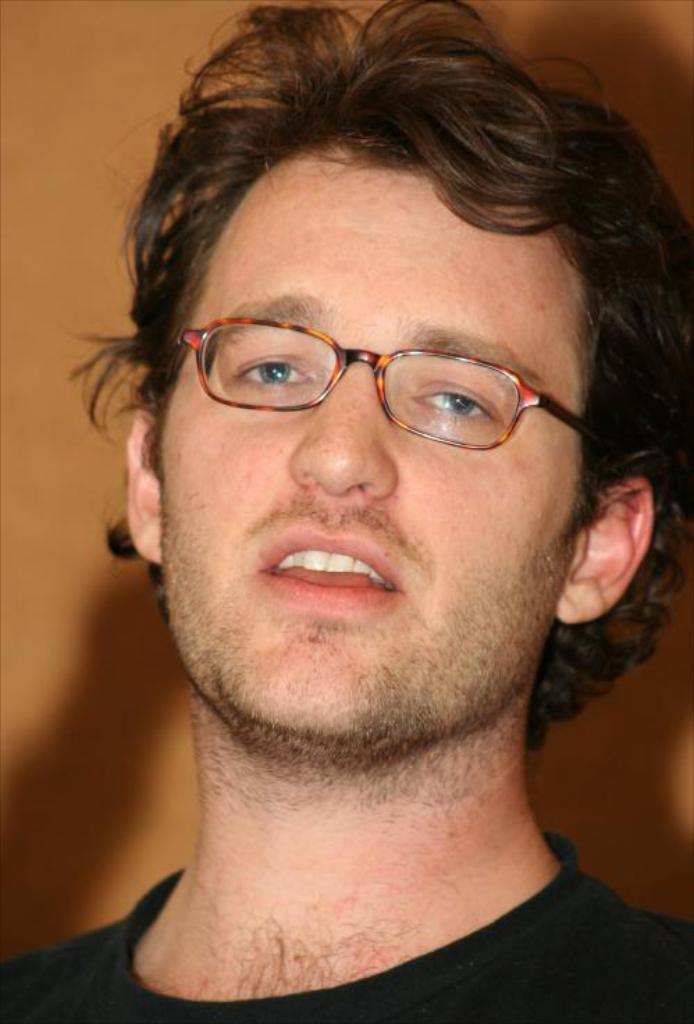Who is present in the image? There is a man in the picture. What is the man wearing on his upper body? The man is wearing a black t-shirt. What accessory is the man wearing on his face? The man is wearing spectacles. What can be seen in the background of the image? There is a wall visible in the background of the picture. What type of title is written on the box in the image? There is no box or title present in the image; it features a man wearing a black t-shirt and spectacles with a wall visible in the background. 